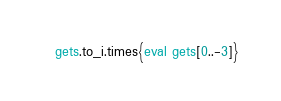<code> <loc_0><loc_0><loc_500><loc_500><_Ruby_>gets.to_i.times{eval gets[0..-3]}</code> 